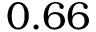<formula> <loc_0><loc_0><loc_500><loc_500>0 . 6 6</formula> 